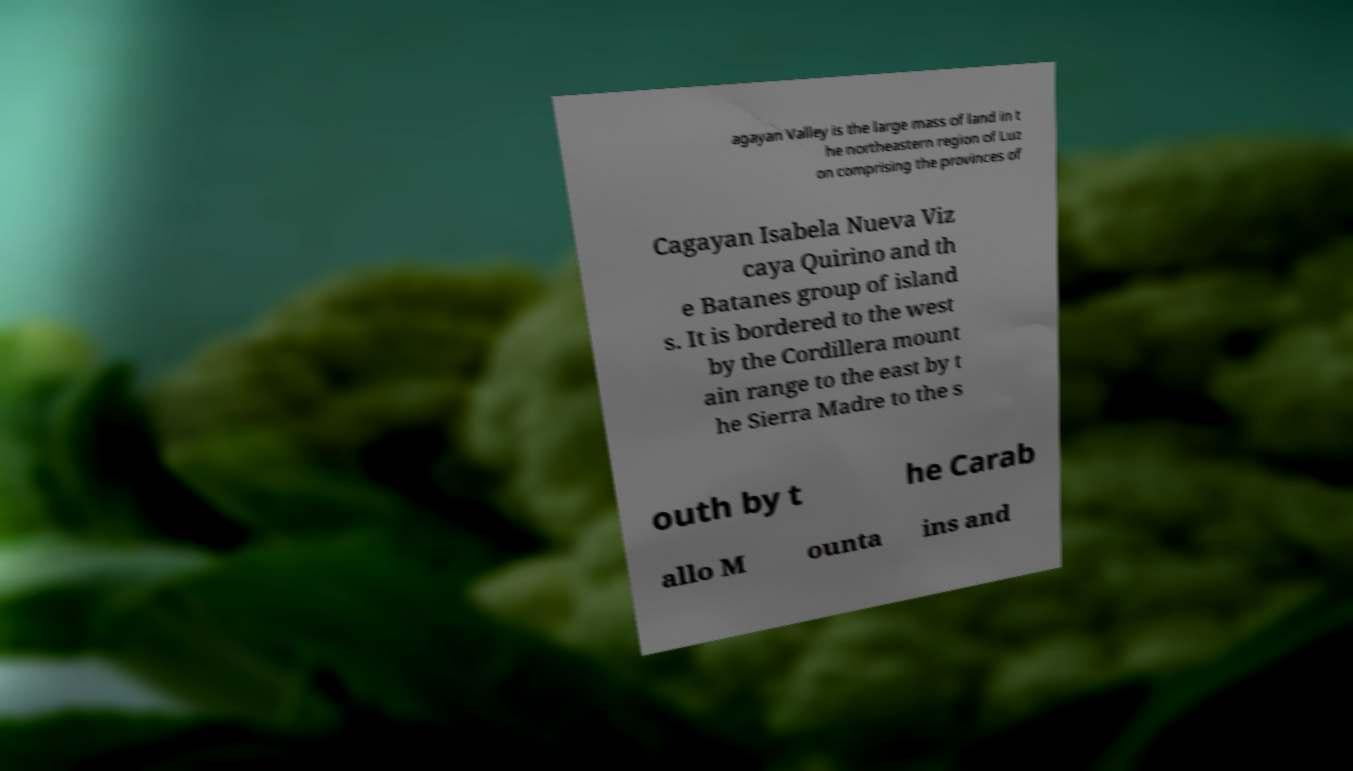Can you accurately transcribe the text from the provided image for me? agayan Valley is the large mass of land in t he northeastern region of Luz on comprising the provinces of Cagayan Isabela Nueva Viz caya Quirino and th e Batanes group of island s. It is bordered to the west by the Cordillera mount ain range to the east by t he Sierra Madre to the s outh by t he Carab allo M ounta ins and 